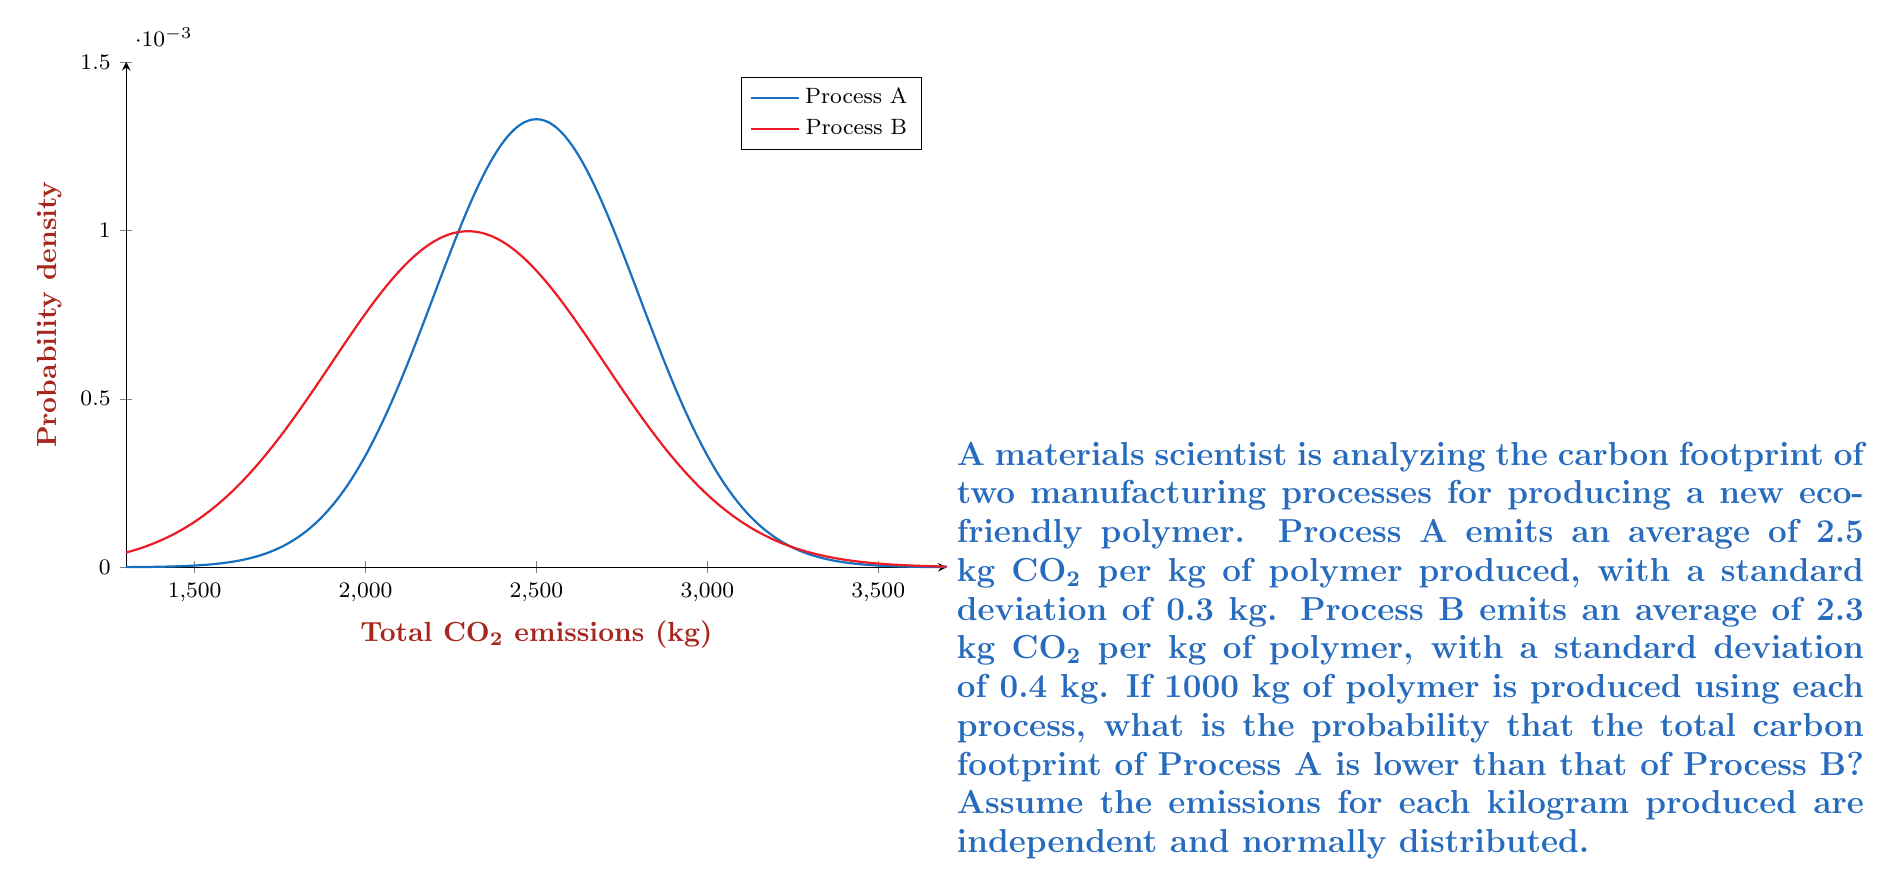Teach me how to tackle this problem. To solve this problem, we'll follow these steps:

1) First, we need to calculate the mean and standard deviation for the total emissions of each process:

   For Process A:
   Mean (μA) = 1000 * 2.5 = 2500 kg CO₂
   Standard deviation (σA) = $\sqrt{1000} * 0.3 = 300\sqrt{10} \approx 9.49$ kg CO₂

   For Process B:
   Mean (μB) = 1000 * 2.3 = 2300 kg CO₂
   Standard deviation (σB) = $\sqrt{1000} * 0.4 = 400\sqrt{10} \approx 12.65$ kg CO₂

2) We want to find P(A < B), which is equivalent to P(A - B < 0).

3) The difference between two normal distributions is also normally distributed. The mean and standard deviation of this new distribution are:

   Mean (μ(A-B)) = μA - μB = 2500 - 2300 = 200 kg CO₂
   
   Standard deviation (σ(A-B)) = $\sqrt{\sigma_A^2 + \sigma_B^2} = \sqrt{(9.49)^2 + (12.65)^2} \approx 15.81$ kg CO₂

4) Now we need to find P(A - B < 0), which is equivalent to finding the z-score for 0 in this new distribution:

   $z = \frac{0 - \mu_{(A-B)}}{\sigma_{(A-B)}} = \frac{0 - 200}{15.81} \approx -12.65$

5) Using a standard normal distribution table or calculator, we can find the probability corresponding to this z-score:

   P(z < -12.65) ≈ 0

Therefore, the probability that the total carbon footprint of Process A is lower than that of Process B is approximately 0.
Answer: $\approx 0$ 